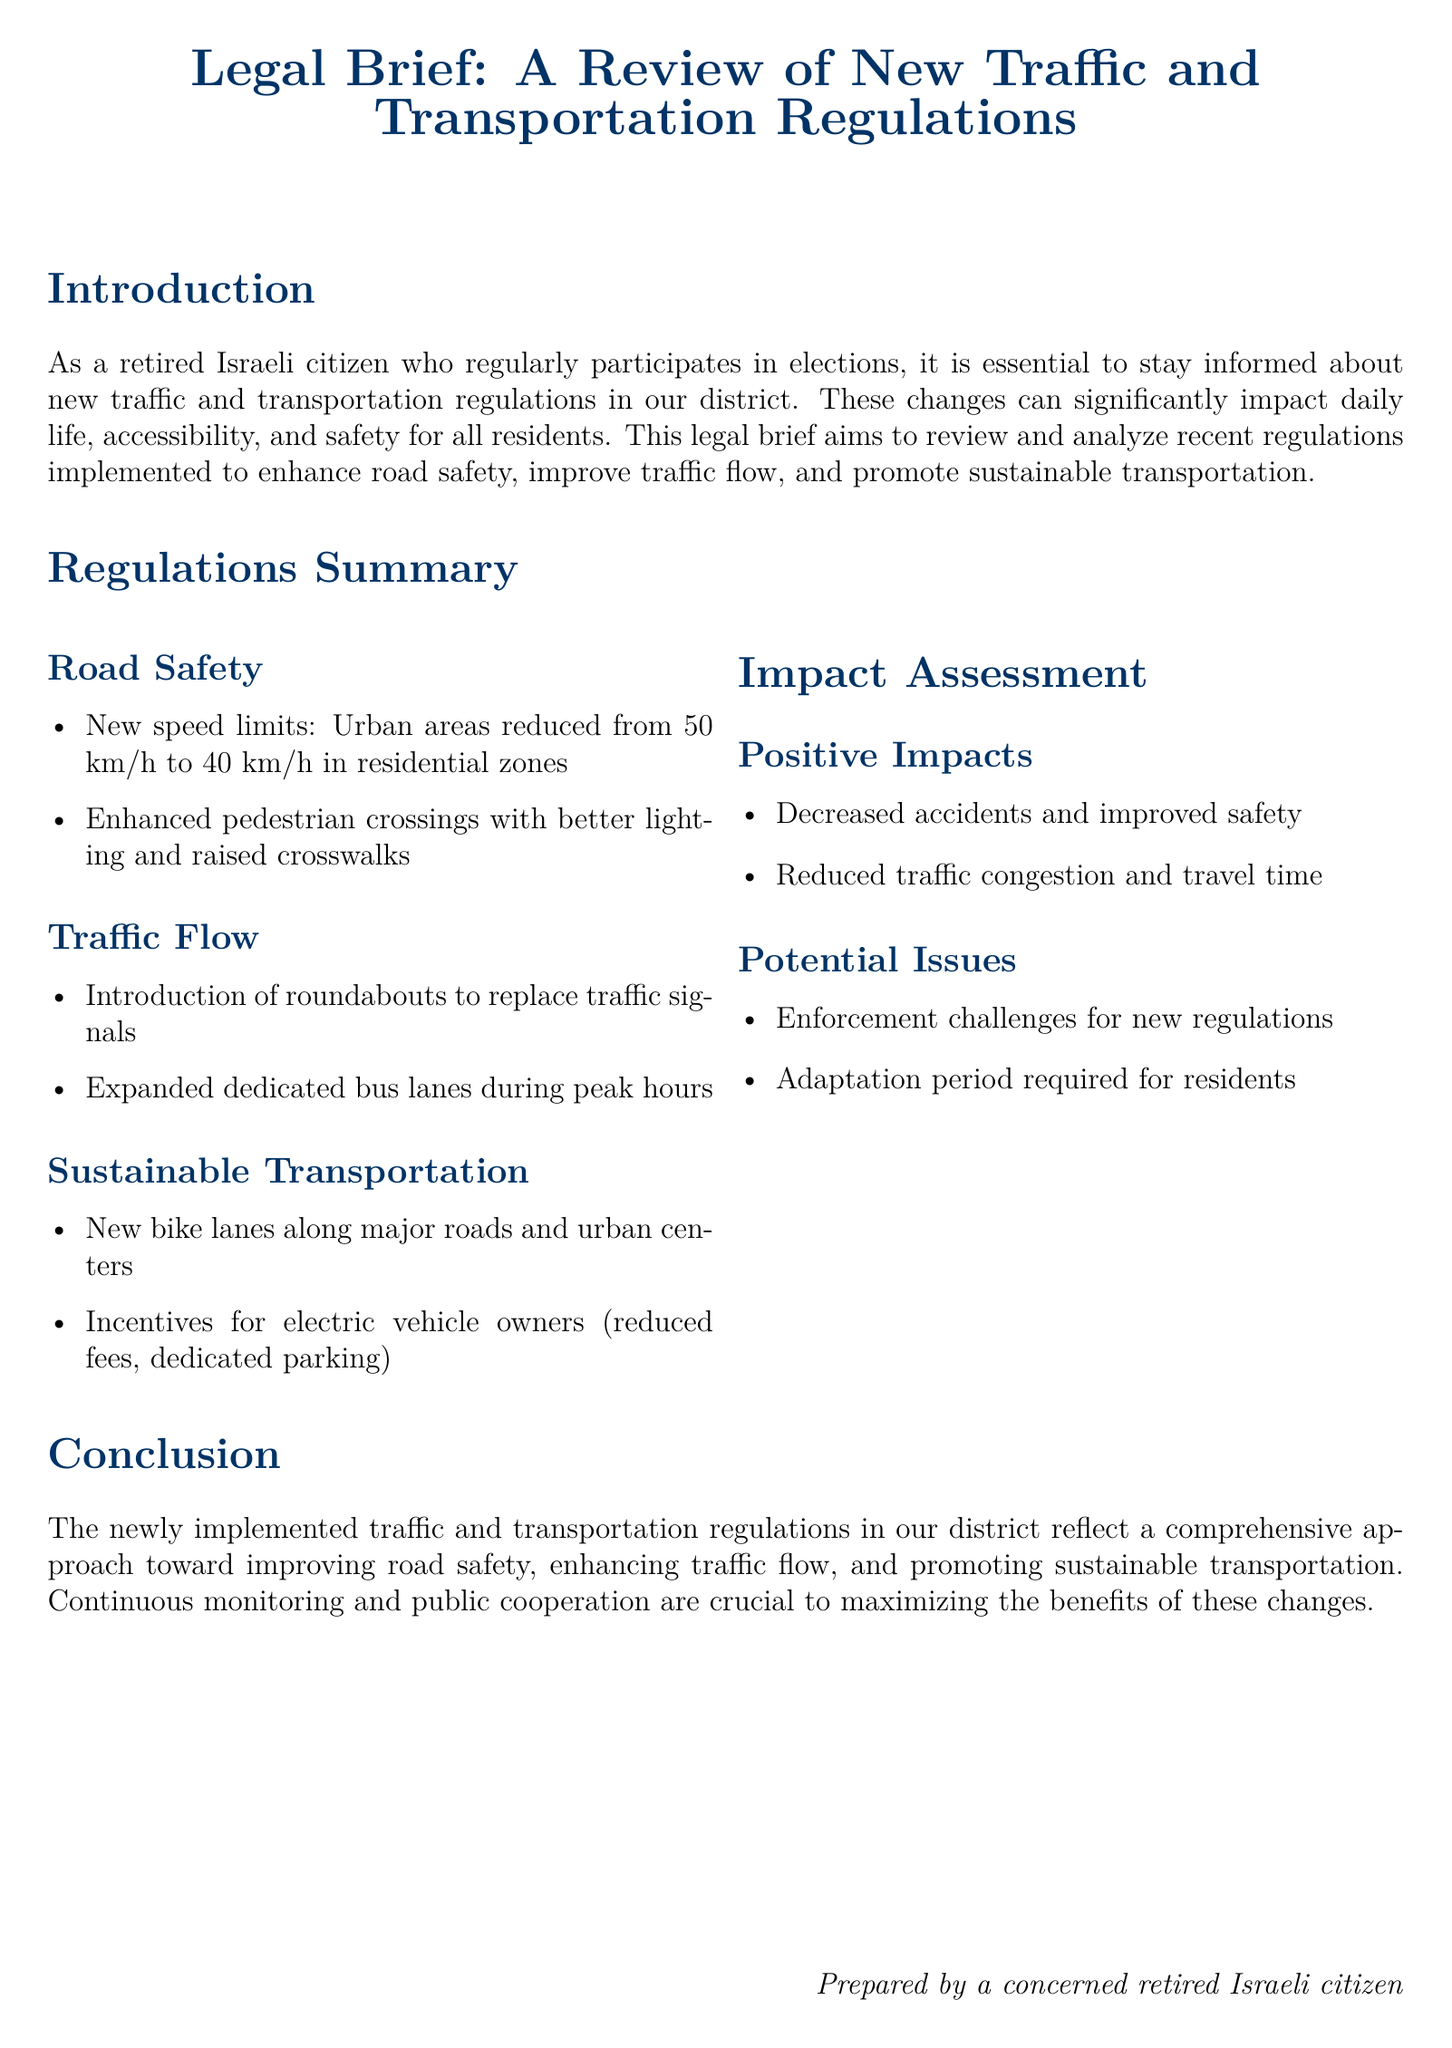what is the new speed limit in urban areas? The document specifies that urban areas speed limits have been reduced from 50 km/h to 40 km/h in residential zones.
Answer: 40 km/h what improvements were made to pedestrian crossings? The document states that pedestrian crossings now have better lighting and raised crosswalks for enhanced safety.
Answer: Better lighting and raised crosswalks what type of transportation lanes were expanded during peak hours? The regulations include expanded dedicated bus lanes specifically during peak hours to improve traffic flow.
Answer: Dedicated bus lanes what are the incentives for electric vehicle owners? The brief mentions reduced fees and dedicated parking as incentives for electric vehicle owners introduced in the new regulations.
Answer: Reduced fees, dedicated parking what are the two positive impacts of the new regulations? The document highlights decreased accidents and improved safety as well as reduced traffic congestion and travel time as positive impacts.
Answer: Decreased accidents, reduced traffic congestion what challenges are associated with the new regulations? The report identifies enforcement challenges and the need for an adaptation period for residents as potential issues.
Answer: Enforcement challenges, adaptation period what is the main focus of the newly implemented regulations? The primary aim of these regulations is to enhance road safety, improve traffic flow, and promote sustainable transportation in the district.
Answer: Road safety, traffic flow, sustainable transportation who prepared the legal brief? At the end of the document, it specifies that the brief was prepared by a concerned retired Israeli citizen.
Answer: A concerned retired Israeli citizen 